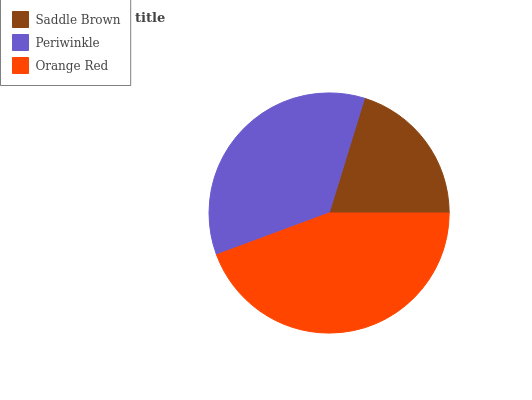Is Saddle Brown the minimum?
Answer yes or no. Yes. Is Orange Red the maximum?
Answer yes or no. Yes. Is Periwinkle the minimum?
Answer yes or no. No. Is Periwinkle the maximum?
Answer yes or no. No. Is Periwinkle greater than Saddle Brown?
Answer yes or no. Yes. Is Saddle Brown less than Periwinkle?
Answer yes or no. Yes. Is Saddle Brown greater than Periwinkle?
Answer yes or no. No. Is Periwinkle less than Saddle Brown?
Answer yes or no. No. Is Periwinkle the high median?
Answer yes or no. Yes. Is Periwinkle the low median?
Answer yes or no. Yes. Is Orange Red the high median?
Answer yes or no. No. Is Orange Red the low median?
Answer yes or no. No. 